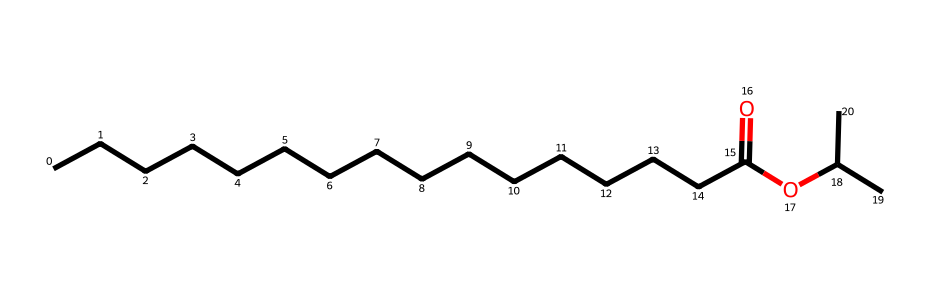What is the molecular formula of isopropyl palmitate? The molecular formula can be deduced from the SMILES representation by counting the number of each type of atom present. In the structure, there are 16 carbon (C) atoms, 32 hydrogen (H) atoms, and 2 oxygen (O) atoms. Therefore, the molecular formula is C16H32O2.
Answer: C16H32O2 How many carbon atoms are in isopropyl palmitate? By examining the SMILES representation, which shows a continuous chain of carbon atoms and side groups, we can count a total of 16 carbon atoms.
Answer: 16 What type of functional group does isopropyl palmitate contain? The functional group can be identified in the SMILES by the carbonyl carbon (C=O) and the adjacent oxygen (O), indicating the presence of an ester functional group.
Answer: ester What is the degree of saturation of isopropyl palmitate? The degree of saturation pertains to the number of double bonds present in the molecule. Since the SMILES shows only one carbonyl double bond and all other carbon bonds are single, isopropyl palmitate is classified as saturated due to no remaining double bonds after accounting for the carbonyl.
Answer: saturated What is the ester origin of isopropyl palmitate? The name indicates that isopropyl palmitate is derived from palmitic acid (a 16-carbon fatty acid) and isopropanol (the alcohol), as seen in the esterification reaction where the hydroxyl group of the acid combines with the alcohol group of isopropanol, forming the ester bond.
Answer: palmitic acid and isopropanol How does the structure of isopropyl palmitate influence its solubility? The long hydrophobic carbon chain (alkyl part) indicates low polarity, while the ester part (C=O and -O) provides some polarity. This balance leads to moderate solubility in both oils and alcohols, suggesting it will dissolve in non-polar and slightly polar solvents.
Answer: moderate solubility What role does isopropyl palmitate play in marine applications? Due to its lubricating properties, derived from its ester structure which provides low viscosity and resistance to oxidation, isopropyl palmitate is frequently utilized in marine lubricants and hydraulic fluids to enhance performance and protect against wear.
Answer: lubricating properties 